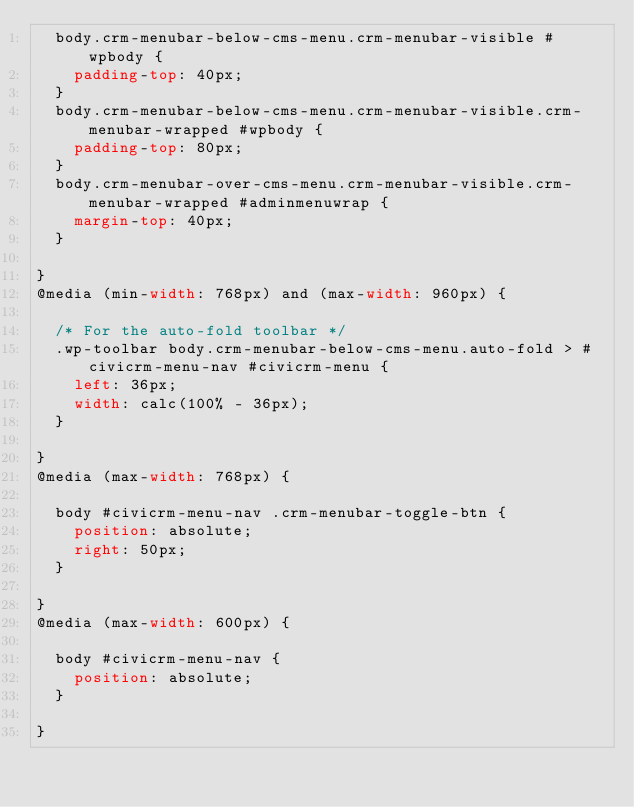<code> <loc_0><loc_0><loc_500><loc_500><_CSS_>  body.crm-menubar-below-cms-menu.crm-menubar-visible #wpbody {
    padding-top: 40px;
  }
  body.crm-menubar-below-cms-menu.crm-menubar-visible.crm-menubar-wrapped #wpbody {
    padding-top: 80px;
  }
  body.crm-menubar-over-cms-menu.crm-menubar-visible.crm-menubar-wrapped #adminmenuwrap {
    margin-top: 40px;
  }

}
@media (min-width: 768px) and (max-width: 960px) {

  /* For the auto-fold toolbar */
  .wp-toolbar body.crm-menubar-below-cms-menu.auto-fold > #civicrm-menu-nav #civicrm-menu {
    left: 36px;
    width: calc(100% - 36px);
  }

}
@media (max-width: 768px) {

  body #civicrm-menu-nav .crm-menubar-toggle-btn {
    position: absolute;
    right: 50px;
  }

}
@media (max-width: 600px) {

  body #civicrm-menu-nav {
    position: absolute;
  }

}
</code> 